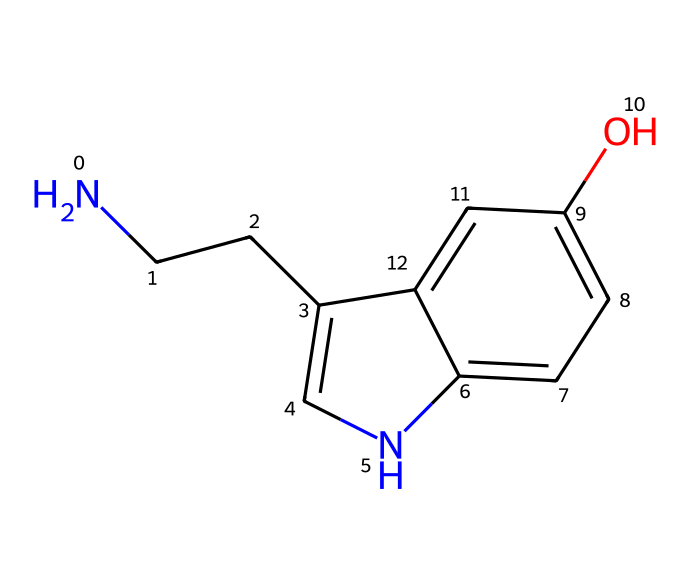What is the chemical name of this compound? The SMILES representation corresponds to a structure known as serotonin, which is identified by its distinct functional groups and connectivity indicated in the structure.
Answer: serotonin How many carbon atoms are present in this compound? Analyzing the SMILES representation, the total number of carbon atoms can be counted, which results in 10 carbon atoms present in the structure.
Answer: 10 How many total nitrogen atoms are in the compound? By examining the structure represented in the SMILES, there is 1 nitrogen atom present, noted particularly by the presence of 'N' in the representation.
Answer: 1 What type of structure does this compound have (cyclic or acyclic)? Examining the rings present in the structure, we see that it contains fused rings, indicating that it is a cyclic compound.
Answer: cyclic Is there a hydroxyl group in this chemical? Looking at the SMILES representation, 'O' is present in a context that indicates a hydroxyl (-OH) group, confirming its presence in the structure.
Answer: yes How many benzene-like rings are in the compound? The structure reveals two interconnected aromatic rings, as can be inferred from the systematic connectivity and presence of 'c' in the SMILES, indicating there are 2.
Answer: 2 What type of functional group is indicated by the nitrogen atom in the structure? The presence of a nitrogen atom connected to the carbon chain suggests it is part of an amine functional group, which is characteristic of serotonin.
Answer: amine 